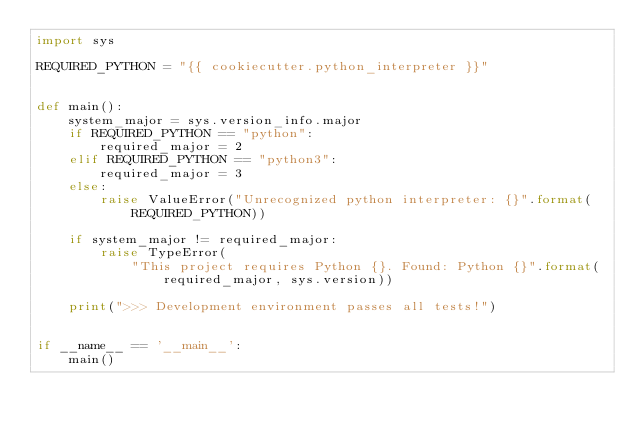<code> <loc_0><loc_0><loc_500><loc_500><_Python_>import sys

REQUIRED_PYTHON = "{{ cookiecutter.python_interpreter }}"


def main():
    system_major = sys.version_info.major
    if REQUIRED_PYTHON == "python":
        required_major = 2
    elif REQUIRED_PYTHON == "python3":
        required_major = 3
    else:
        raise ValueError("Unrecognized python interpreter: {}".format(
            REQUIRED_PYTHON))

    if system_major != required_major:
        raise TypeError(
            "This project requires Python {}. Found: Python {}".format(
                required_major, sys.version))

    print(">>> Development environment passes all tests!")


if __name__ == '__main__':
    main()
</code> 